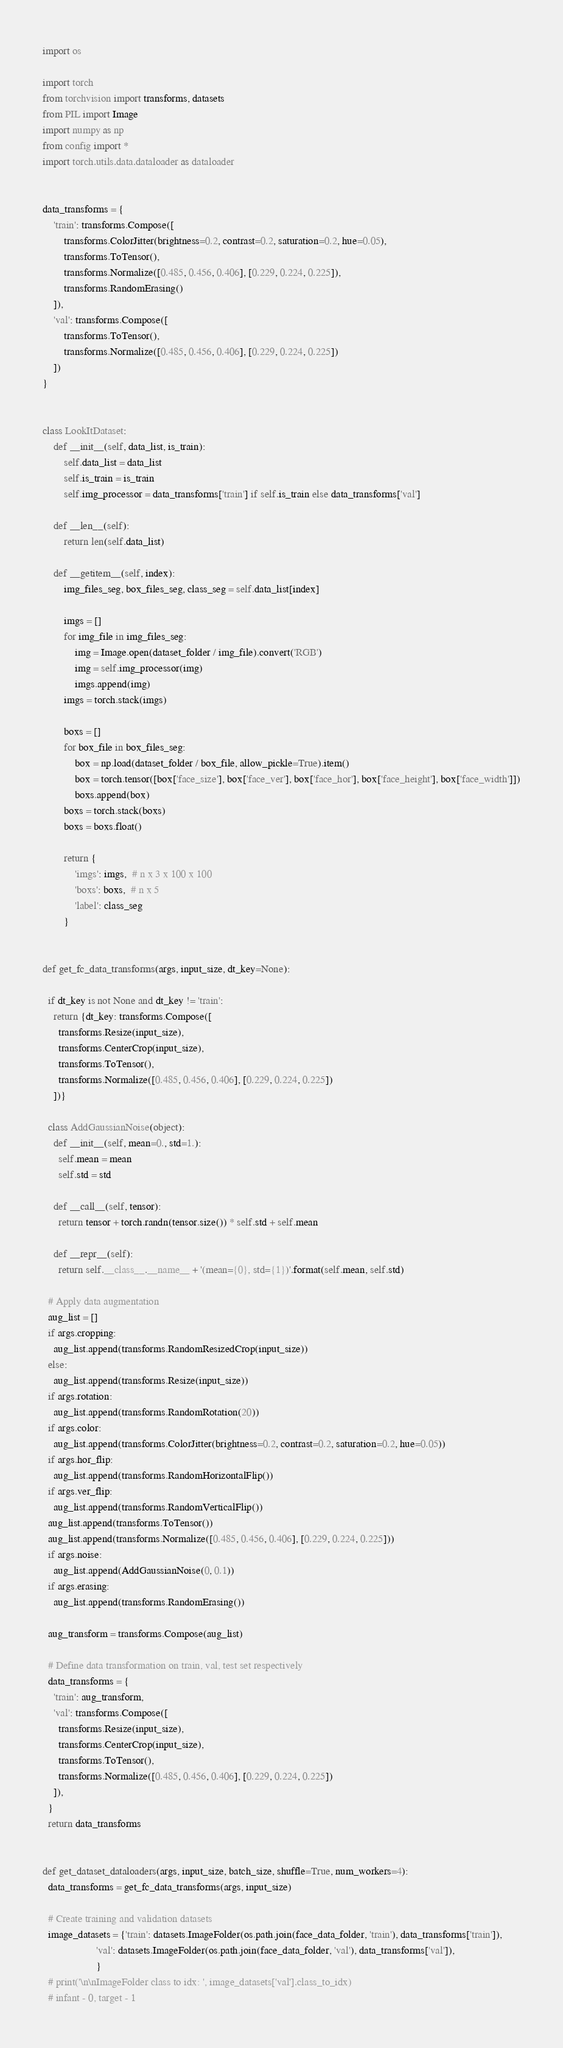Convert code to text. <code><loc_0><loc_0><loc_500><loc_500><_Python_>import os

import torch
from torchvision import transforms, datasets
from PIL import Image
import numpy as np
from config import *
import torch.utils.data.dataloader as dataloader


data_transforms = {
    'train': transforms.Compose([
        transforms.ColorJitter(brightness=0.2, contrast=0.2, saturation=0.2, hue=0.05),
        transforms.ToTensor(),
        transforms.Normalize([0.485, 0.456, 0.406], [0.229, 0.224, 0.225]),
        transforms.RandomErasing()
    ]),
    'val': transforms.Compose([
        transforms.ToTensor(),
        transforms.Normalize([0.485, 0.456, 0.406], [0.229, 0.224, 0.225])
    ])
}


class LookItDataset:
    def __init__(self, data_list, is_train):
        self.data_list = data_list
        self.is_train = is_train
        self.img_processor = data_transforms['train'] if self.is_train else data_transforms['val']

    def __len__(self):
        return len(self.data_list)

    def __getitem__(self, index):
        img_files_seg, box_files_seg, class_seg = self.data_list[index]

        imgs = []
        for img_file in img_files_seg:
            img = Image.open(dataset_folder / img_file).convert('RGB')
            img = self.img_processor(img)
            imgs.append(img)
        imgs = torch.stack(imgs)

        boxs = []
        for box_file in box_files_seg:
            box = np.load(dataset_folder / box_file, allow_pickle=True).item()
            box = torch.tensor([box['face_size'], box['face_ver'], box['face_hor'], box['face_height'], box['face_width']])
            boxs.append(box)
        boxs = torch.stack(boxs)
        boxs = boxs.float()

        return {
            'imgs': imgs,  # n x 3 x 100 x 100
            'boxs': boxs,  # n x 5
            'label': class_seg
        }


def get_fc_data_transforms(args, input_size, dt_key=None):

  if dt_key is not None and dt_key != 'train':
    return {dt_key: transforms.Compose([
      transforms.Resize(input_size),
      transforms.CenterCrop(input_size),
      transforms.ToTensor(),
      transforms.Normalize([0.485, 0.456, 0.406], [0.229, 0.224, 0.225])
    ])}

  class AddGaussianNoise(object):
    def __init__(self, mean=0., std=1.):
      self.mean = mean
      self.std = std

    def __call__(self, tensor):
      return tensor + torch.randn(tensor.size()) * self.std + self.mean

    def __repr__(self):
      return self.__class__.__name__ + '(mean={0}, std={1})'.format(self.mean, self.std)

  # Apply data augmentation
  aug_list = []
  if args.cropping:
    aug_list.append(transforms.RandomResizedCrop(input_size))
  else:
    aug_list.append(transforms.Resize(input_size))
  if args.rotation:
    aug_list.append(transforms.RandomRotation(20))
  if args.color:
    aug_list.append(transforms.ColorJitter(brightness=0.2, contrast=0.2, saturation=0.2, hue=0.05))
  if args.hor_flip:
    aug_list.append(transforms.RandomHorizontalFlip())
  if args.ver_flip:
    aug_list.append(transforms.RandomVerticalFlip())
  aug_list.append(transforms.ToTensor())
  aug_list.append(transforms.Normalize([0.485, 0.456, 0.406], [0.229, 0.224, 0.225]))
  if args.noise:
    aug_list.append(AddGaussianNoise(0, 0.1))
  if args.erasing:
    aug_list.append(transforms.RandomErasing())

  aug_transform = transforms.Compose(aug_list)

  # Define data transformation on train, val, test set respectively
  data_transforms = {
    'train': aug_transform,
    'val': transforms.Compose([
      transforms.Resize(input_size),
      transforms.CenterCrop(input_size),
      transforms.ToTensor(),
      transforms.Normalize([0.485, 0.456, 0.406], [0.229, 0.224, 0.225])
    ]),
  }
  return data_transforms


def get_dataset_dataloaders(args, input_size, batch_size, shuffle=True, num_workers=4):
  data_transforms = get_fc_data_transforms(args, input_size)

  # Create training and validation datasets
  image_datasets = {'train': datasets.ImageFolder(os.path.join(face_data_folder, 'train'), data_transforms['train']),
                    'val': datasets.ImageFolder(os.path.join(face_data_folder, 'val'), data_transforms['val']),
                    }
  # print('\n\nImageFolder class to idx: ', image_datasets['val'].class_to_idx)
  # infant - 0, target - 1</code> 